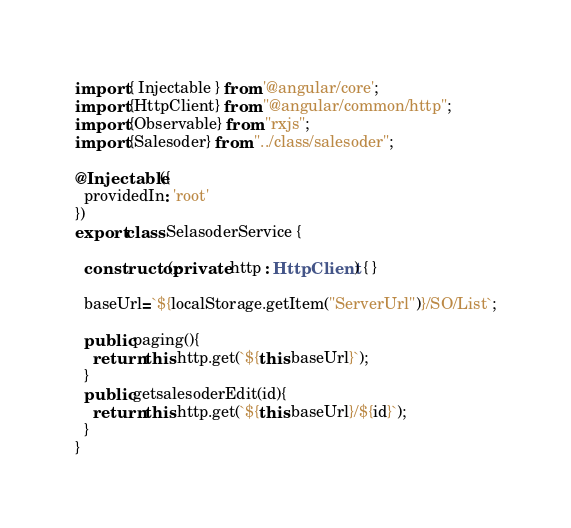<code> <loc_0><loc_0><loc_500><loc_500><_TypeScript_>import { Injectable } from '@angular/core';
import {HttpClient} from "@angular/common/http";
import {Observable} from "rxjs";
import {Salesoder} from "../class/salesoder";

@Injectable({
  providedIn: 'root'
})
export class SelasoderService {

  constructor(private http : HttpClient) { }

  baseUrl=`${localStorage.getItem("ServerUrl")}/SO/List`;

  public paging(){
    return this.http.get(`${this.baseUrl}`);
  }
  public getsalesoderEdit(id){
    return this.http.get(`${this.baseUrl}/${id}`);
  }
}
</code> 